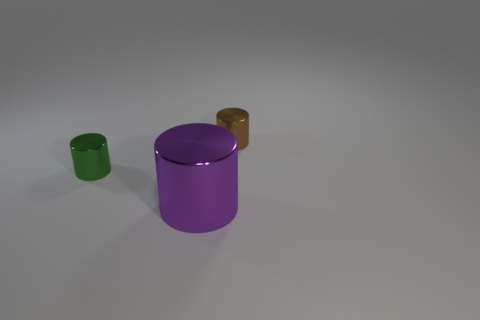There is a thing in front of the small metal cylinder left of the tiny brown thing; what number of tiny green cylinders are to the right of it? Upon observation of the image, there are no tiny green cylinders to the right of the small metal cylinder in question. Therefore, the number of tiny green cylinders in that particular location is zero. 